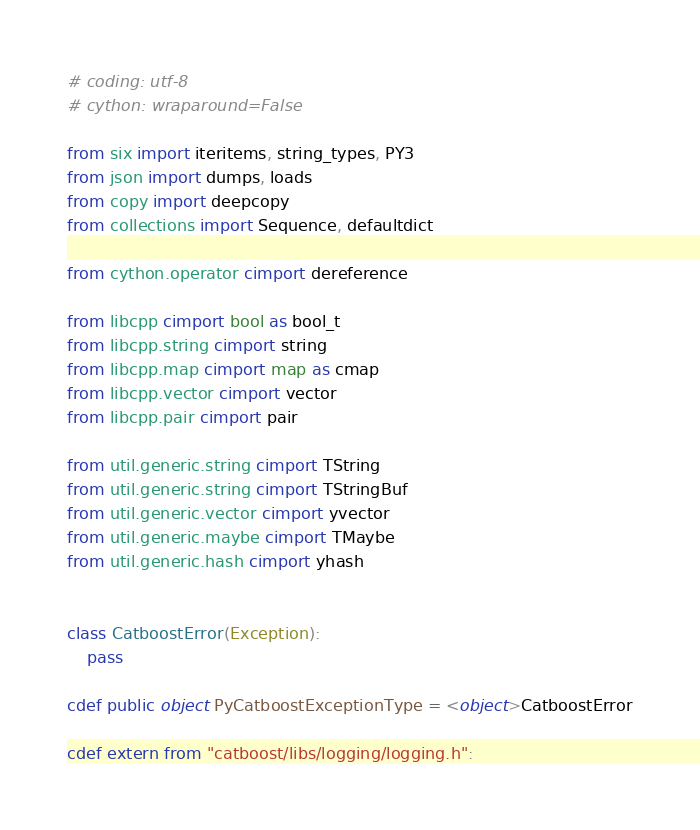<code> <loc_0><loc_0><loc_500><loc_500><_Cython_># coding: utf-8
# cython: wraparound=False

from six import iteritems, string_types, PY3
from json import dumps, loads
from copy import deepcopy
from collections import Sequence, defaultdict

from cython.operator cimport dereference

from libcpp cimport bool as bool_t
from libcpp.string cimport string
from libcpp.map cimport map as cmap
from libcpp.vector cimport vector
from libcpp.pair cimport pair

from util.generic.string cimport TString
from util.generic.string cimport TStringBuf
from util.generic.vector cimport yvector
from util.generic.maybe cimport TMaybe
from util.generic.hash cimport yhash


class CatboostError(Exception):
    pass

cdef public object PyCatboostExceptionType = <object>CatboostError

cdef extern from "catboost/libs/logging/logging.h":</code> 